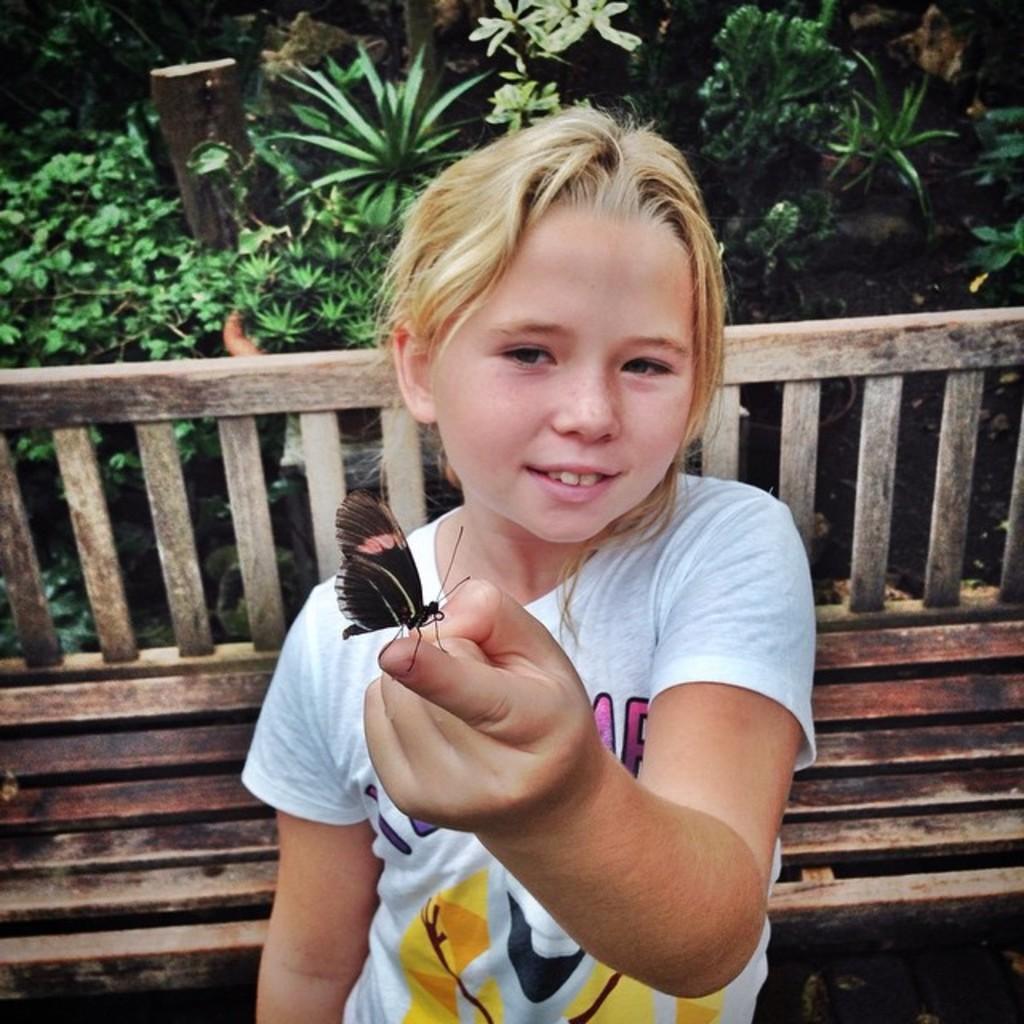How would you summarize this image in a sentence or two? In this image there is a girl standing and holding a butterfly, and in the background there is a bench and plants. 